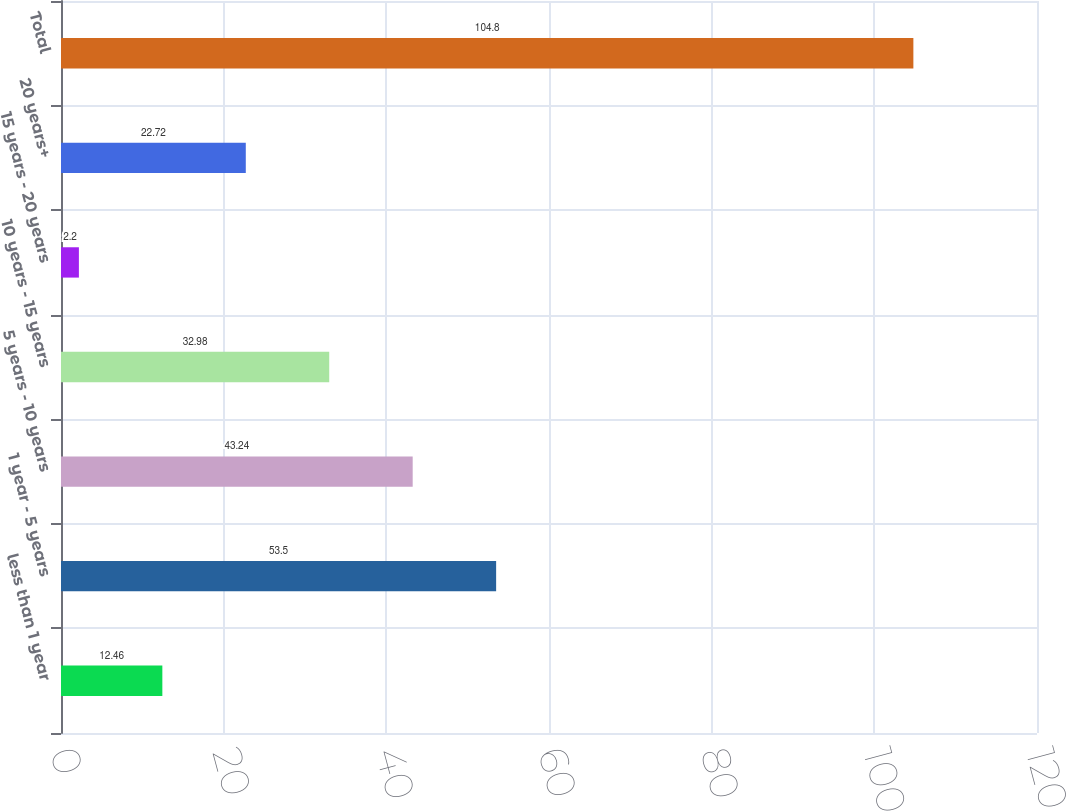Convert chart. <chart><loc_0><loc_0><loc_500><loc_500><bar_chart><fcel>less than 1 year<fcel>1 year - 5 years<fcel>5 years - 10 years<fcel>10 years - 15 years<fcel>15 years - 20 years<fcel>20 years+<fcel>Total<nl><fcel>12.46<fcel>53.5<fcel>43.24<fcel>32.98<fcel>2.2<fcel>22.72<fcel>104.8<nl></chart> 